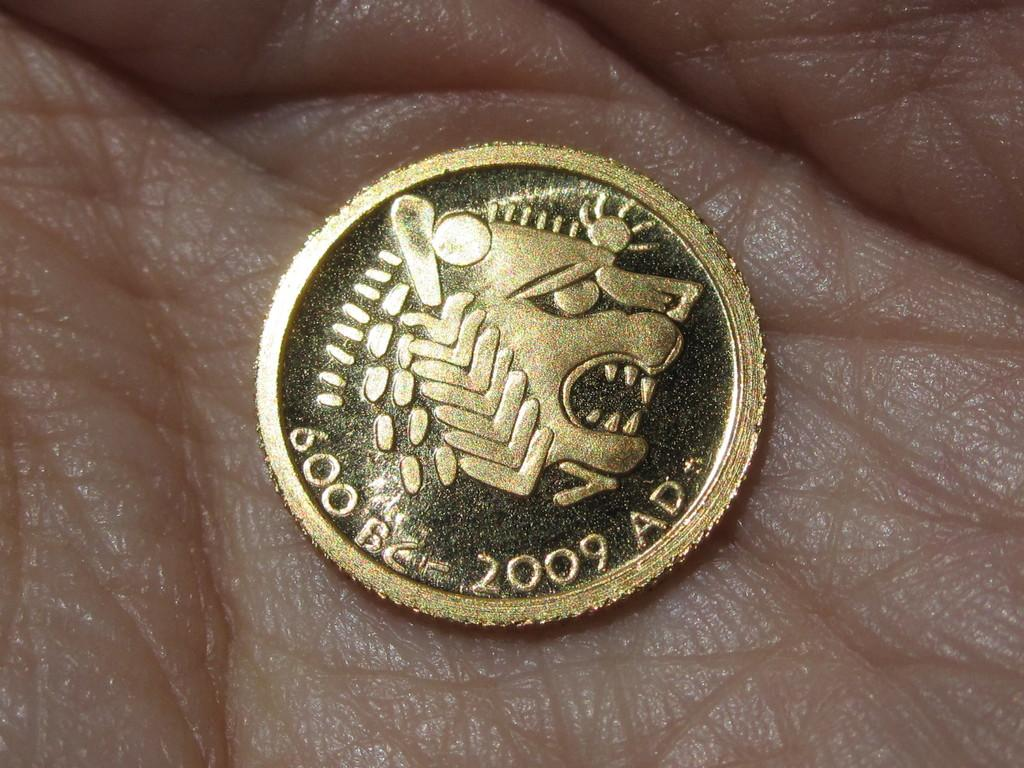<image>
Relay a brief, clear account of the picture shown. A coin celebrates the years between 600 BC and 2009 AD. 